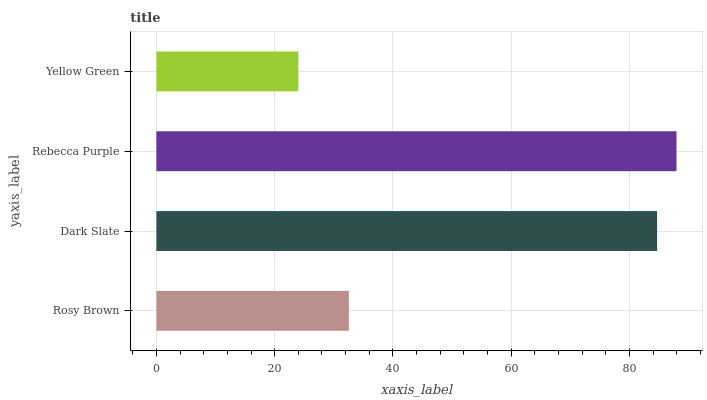Is Yellow Green the minimum?
Answer yes or no. Yes. Is Rebecca Purple the maximum?
Answer yes or no. Yes. Is Dark Slate the minimum?
Answer yes or no. No. Is Dark Slate the maximum?
Answer yes or no. No. Is Dark Slate greater than Rosy Brown?
Answer yes or no. Yes. Is Rosy Brown less than Dark Slate?
Answer yes or no. Yes. Is Rosy Brown greater than Dark Slate?
Answer yes or no. No. Is Dark Slate less than Rosy Brown?
Answer yes or no. No. Is Dark Slate the high median?
Answer yes or no. Yes. Is Rosy Brown the low median?
Answer yes or no. Yes. Is Yellow Green the high median?
Answer yes or no. No. Is Dark Slate the low median?
Answer yes or no. No. 